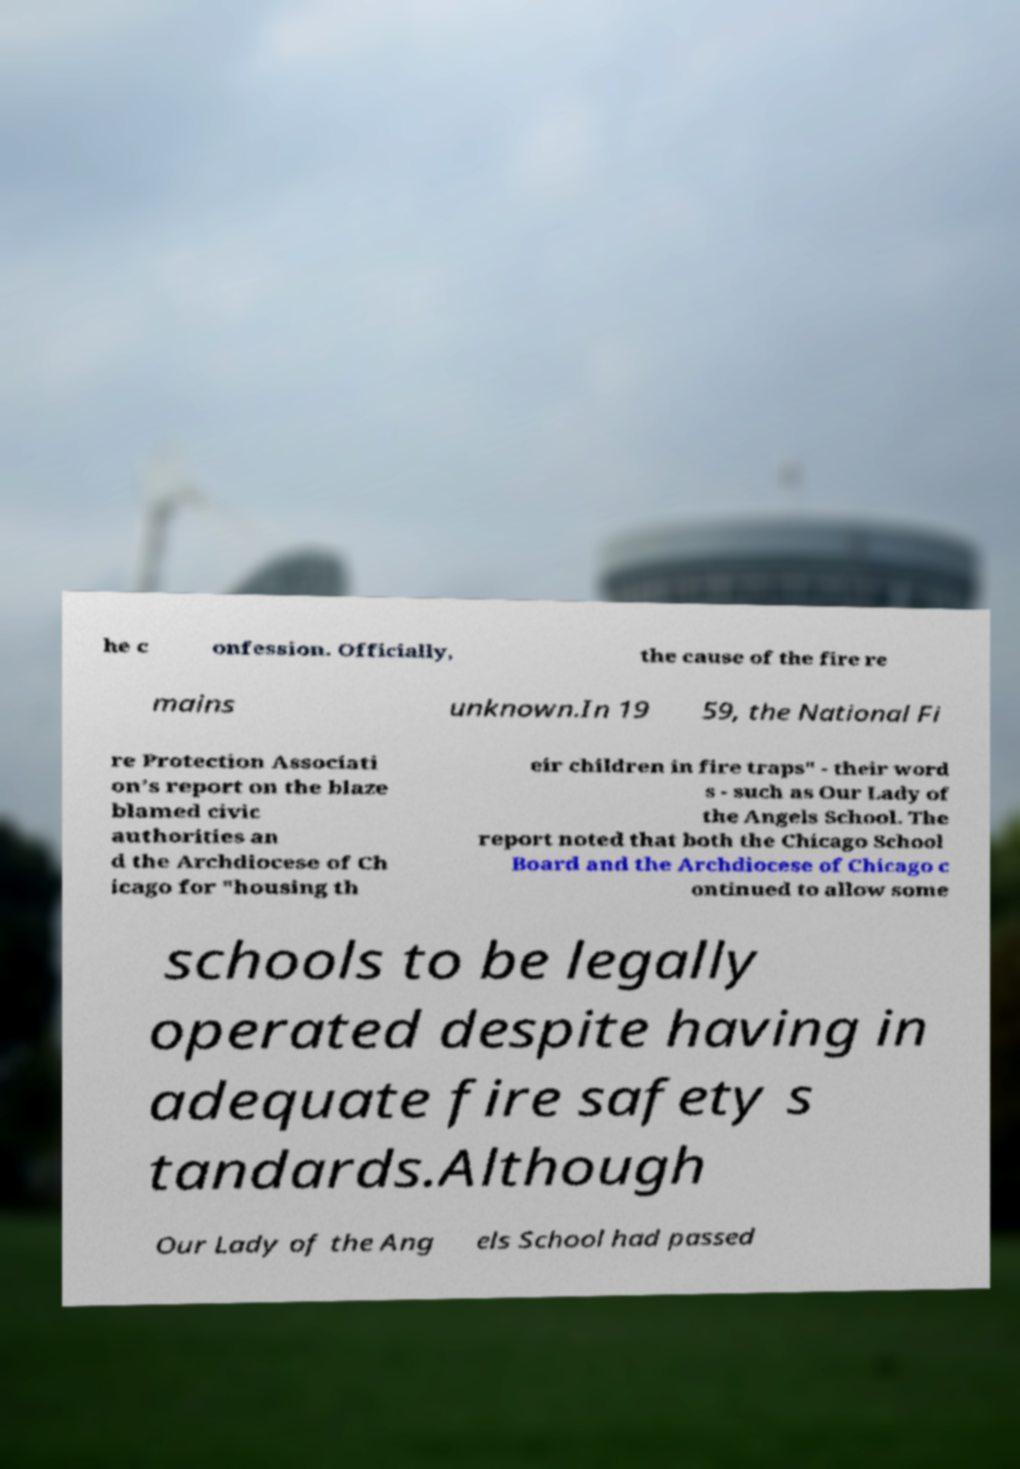Please read and relay the text visible in this image. What does it say? he c onfession. Officially, the cause of the fire re mains unknown.In 19 59, the National Fi re Protection Associati on’s report on the blaze blamed civic authorities an d the Archdiocese of Ch icago for "housing th eir children in fire traps" - their word s - such as Our Lady of the Angels School. The report noted that both the Chicago School Board and the Archdiocese of Chicago c ontinued to allow some schools to be legally operated despite having in adequate fire safety s tandards.Although Our Lady of the Ang els School had passed 